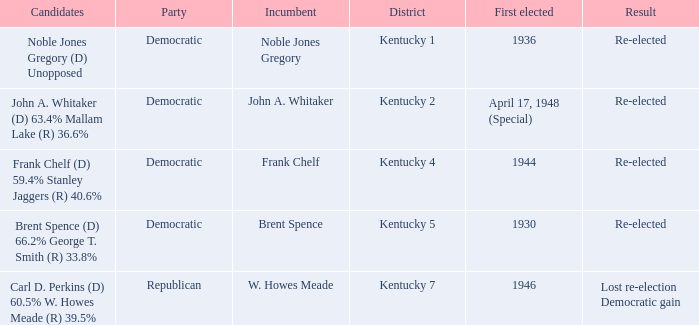Who were the candidates in the Kentucky 4 voting district? Frank Chelf (D) 59.4% Stanley Jaggers (R) 40.6%. 